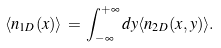<formula> <loc_0><loc_0><loc_500><loc_500>\langle n _ { 1 D } ( x ) \rangle \, = \, \int _ { - \infty } ^ { + \infty } d y \langle n _ { 2 D } ( x , y ) \rangle .</formula> 